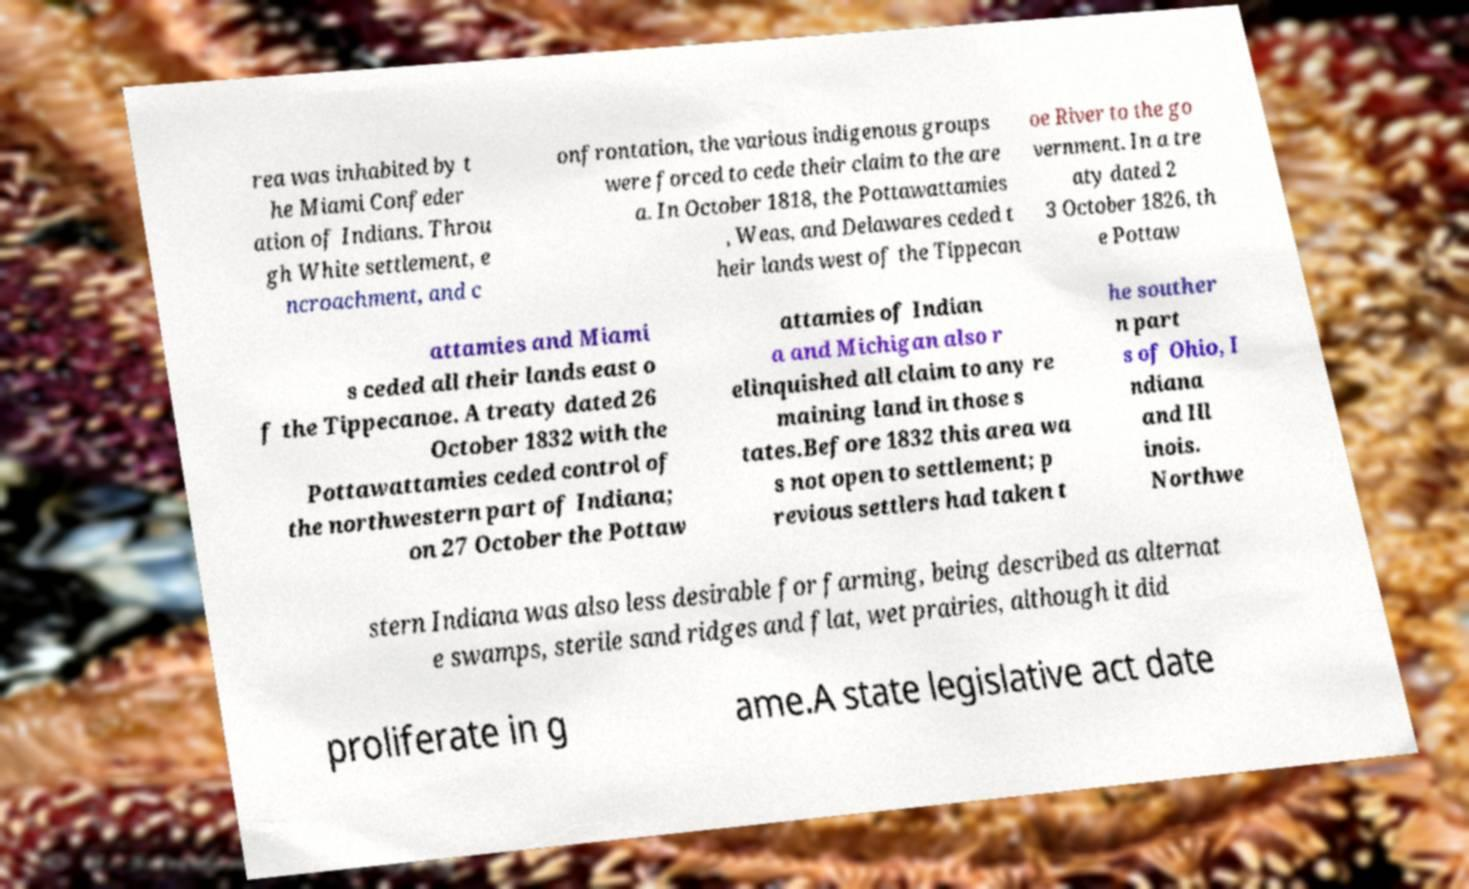Could you extract and type out the text from this image? rea was inhabited by t he Miami Confeder ation of Indians. Throu gh White settlement, e ncroachment, and c onfrontation, the various indigenous groups were forced to cede their claim to the are a. In October 1818, the Pottawattamies , Weas, and Delawares ceded t heir lands west of the Tippecan oe River to the go vernment. In a tre aty dated 2 3 October 1826, th e Pottaw attamies and Miami s ceded all their lands east o f the Tippecanoe. A treaty dated 26 October 1832 with the Pottawattamies ceded control of the northwestern part of Indiana; on 27 October the Pottaw attamies of Indian a and Michigan also r elinquished all claim to any re maining land in those s tates.Before 1832 this area wa s not open to settlement; p revious settlers had taken t he souther n part s of Ohio, I ndiana and Ill inois. Northwe stern Indiana was also less desirable for farming, being described as alternat e swamps, sterile sand ridges and flat, wet prairies, although it did proliferate in g ame.A state legislative act date 